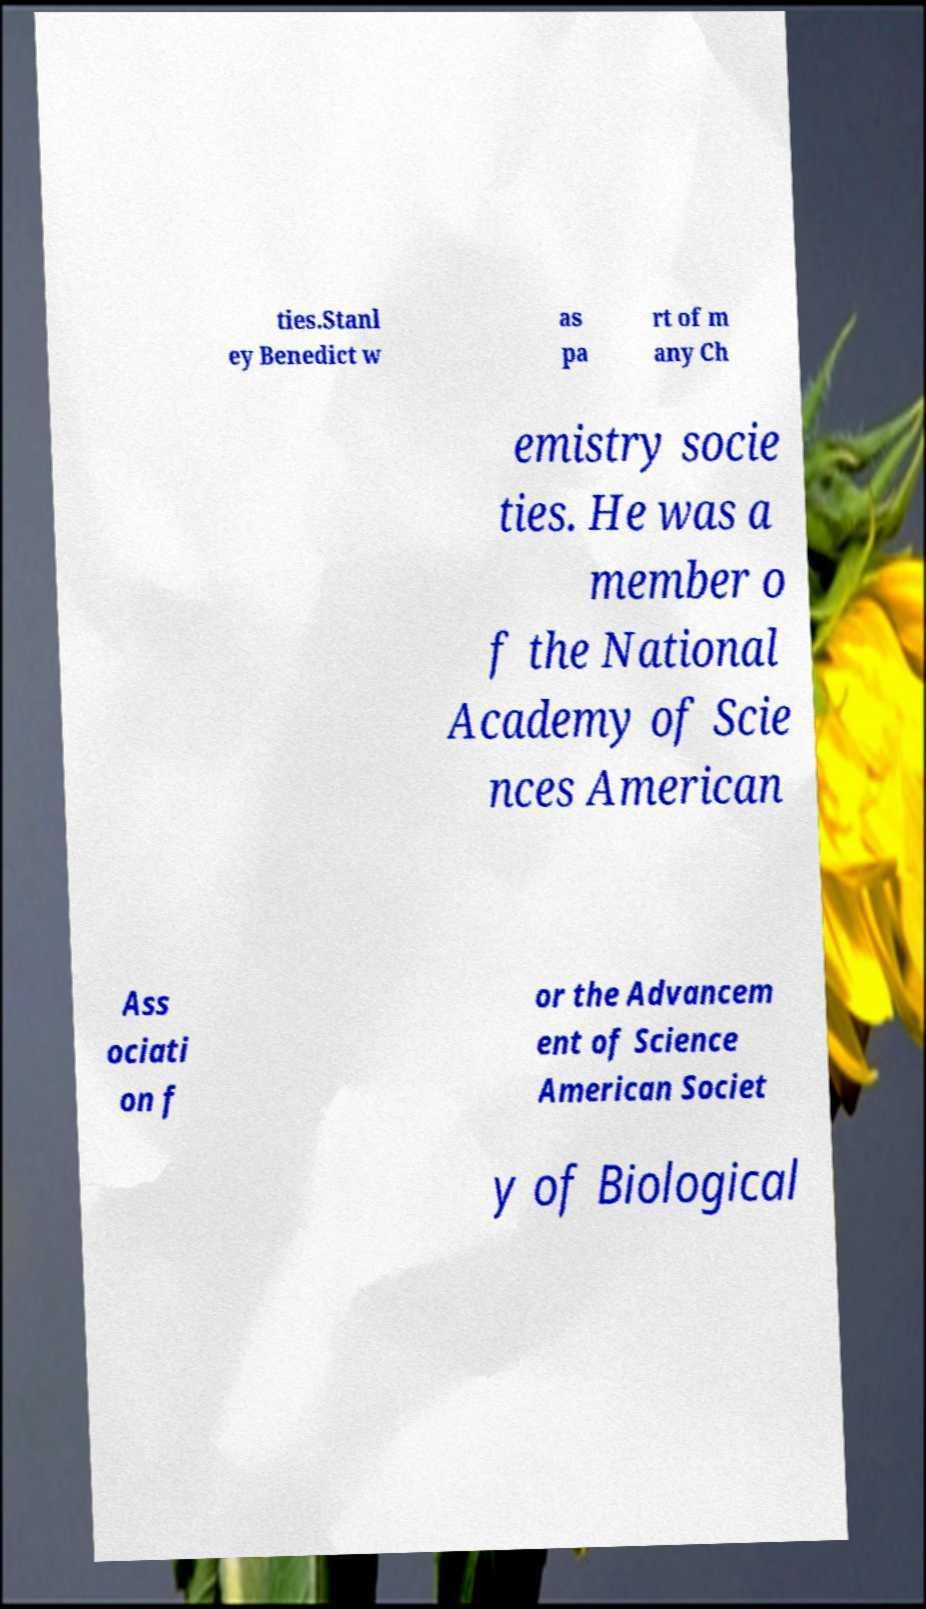Can you accurately transcribe the text from the provided image for me? ties.Stanl ey Benedict w as pa rt of m any Ch emistry socie ties. He was a member o f the National Academy of Scie nces American Ass ociati on f or the Advancem ent of Science American Societ y of Biological 